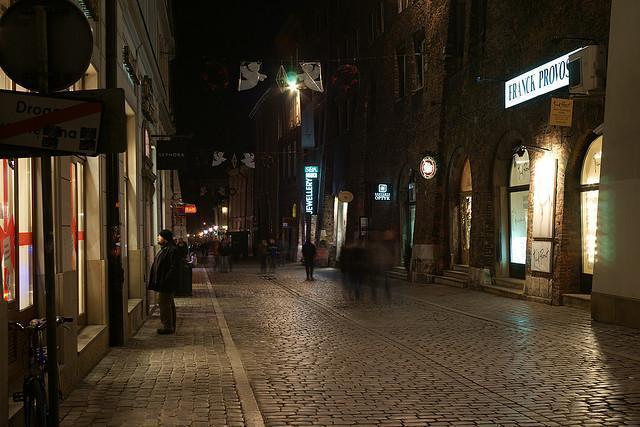What zone is depicted in the photo?
Choose the correct response, then elucidate: 'Answer: answer
Rationale: rationale.'
Options: Residential, traffic, business, shopping. Answer: shopping.
Rationale: There are many shops. 